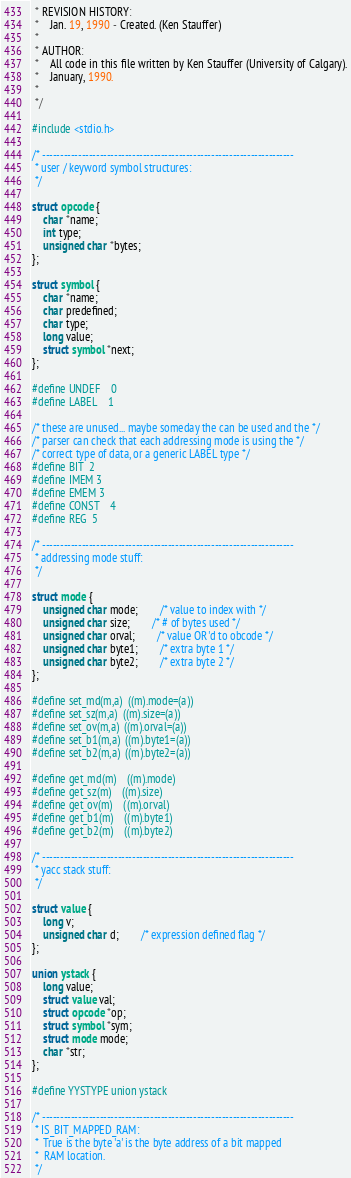Convert code to text. <code><loc_0><loc_0><loc_500><loc_500><_C_> * REVISION HISTORY:
 *	Jan. 19, 1990 - Created. (Ken Stauffer)
 *
 * AUTHOR:
 *	All code in this file written by Ken Stauffer (University of Calgary).
 *	January, 1990.
 *
 */

#include <stdio.h>

/* ----------------------------------------------------------------------
 * user / keyword symbol structures:
 */

struct opcode {
	char *name;
	int type;
	unsigned char *bytes;
};

struct symbol {
	char *name;
	char predefined;
	char type;
	long value;
	struct symbol *next;
};

#define UNDEF	0
#define LABEL	1

/* these are unused... maybe someday the can be used and the */
/* parser can check that each addressing mode is using the */
/* correct type of data, or a generic LABEL type */
#define BIT	2
#define IMEM	3
#define EMEM	3
#define CONST	4
#define REG	5

/* ----------------------------------------------------------------------
 * addressing mode stuff:
 */

struct mode {
	unsigned char mode;		/* value to index with */
	unsigned char size;		/* # of bytes used */
	unsigned char orval;		/* value OR'd to obcode */
	unsigned char byte1;		/* extra byte 1 */
	unsigned char byte2;		/* extra byte 2 */
};

#define set_md(m,a)	((m).mode=(a))
#define set_sz(m,a)	((m).size=(a))
#define set_ov(m,a)	((m).orval=(a))
#define set_b1(m,a)	((m).byte1=(a))
#define set_b2(m,a)	((m).byte2=(a))

#define get_md(m)	((m).mode)
#define get_sz(m)	((m).size)
#define get_ov(m)	((m).orval)
#define get_b1(m)	((m).byte1)
#define get_b2(m)	((m).byte2)

/* ----------------------------------------------------------------------
 * yacc stack stuff:
 */

struct value {
	long v;
	unsigned char d;		/* expression defined flag */
};

union ystack {
	long value;
	struct value val;
	struct opcode *op;
	struct symbol *sym;
	struct mode mode;
	char *str;
};

#define YYSTYPE union ystack

/* ----------------------------------------------------------------------
 * IS_BIT_MAPPED_RAM:
 *	True is the byte 'a' is the byte address of a bit mapped
 *	RAM location.
 */</code> 